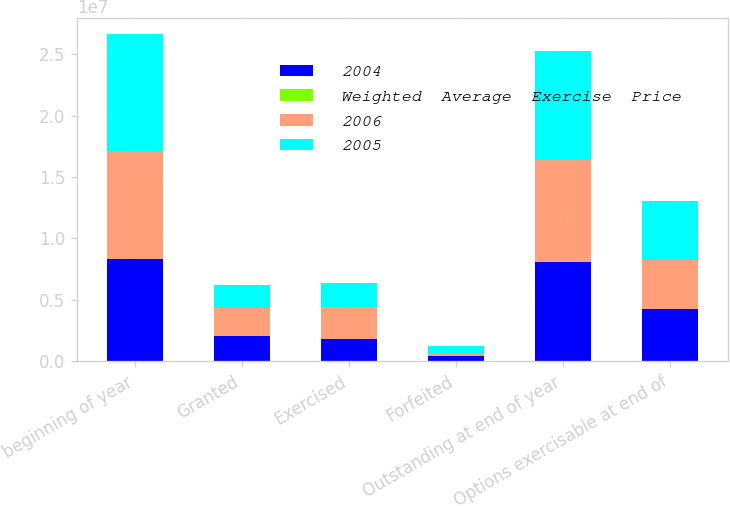Convert chart. <chart><loc_0><loc_0><loc_500><loc_500><stacked_bar_chart><ecel><fcel>beginning of year<fcel>Granted<fcel>Exercised<fcel>Forfeited<fcel>Outstanding at end of year<fcel>Options exercisable at end of<nl><fcel>2004<fcel>8.30141e+06<fcel>2.0307e+06<fcel>1.80565e+06<fcel>423568<fcel>8.10289e+06<fcel>4.26274e+06<nl><fcel>Weighted  Average  Exercise  Price<fcel>19.38<fcel>38.17<fcel>17.06<fcel>26.09<fcel>24.26<fcel>18.03<nl><fcel>2006<fcel>8.83271e+06<fcel>2.33665e+06<fcel>2.63325e+06<fcel>234708<fcel>8.30141e+06<fcel>3.98775e+06<nl><fcel>2005<fcel>9.49036e+06<fcel>1.82047e+06<fcel>1.91678e+06<fcel>561336<fcel>8.83271e+06<fcel>4.81316e+06<nl></chart> 